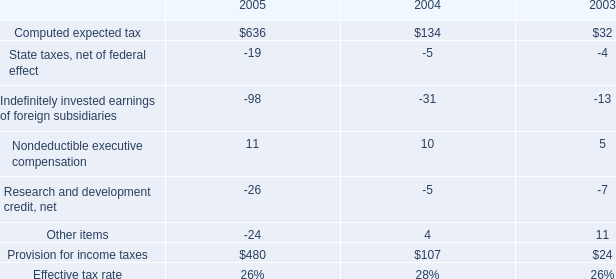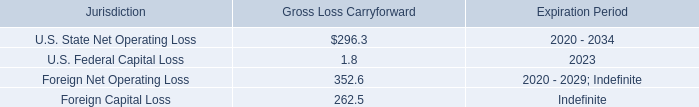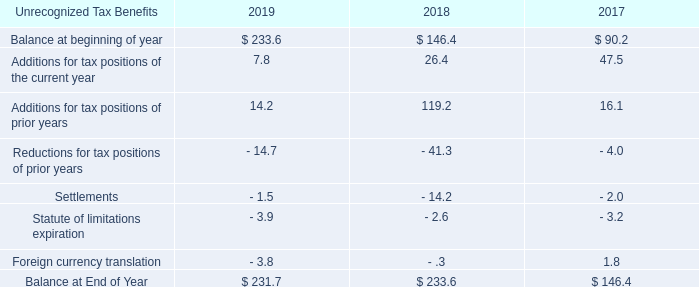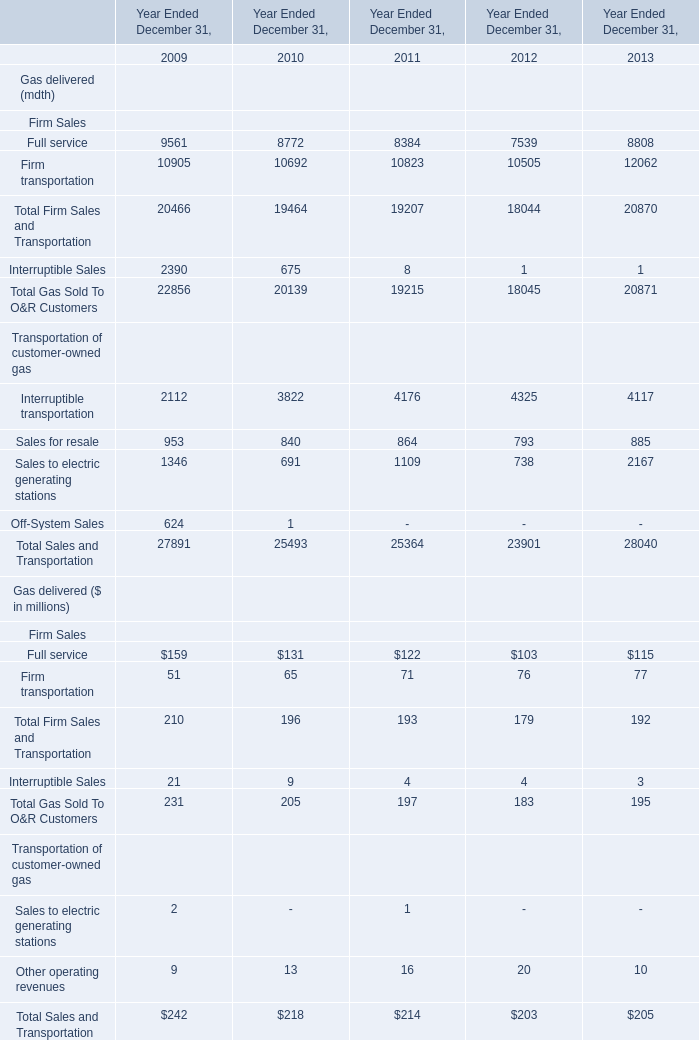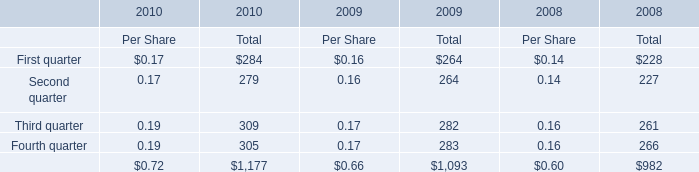What's the current growth rate of Total Sales and Transportation in terms of Gas delivered ($ in millions)? 
Computations: ((205 - 203) / 203)
Answer: 0.00985. 